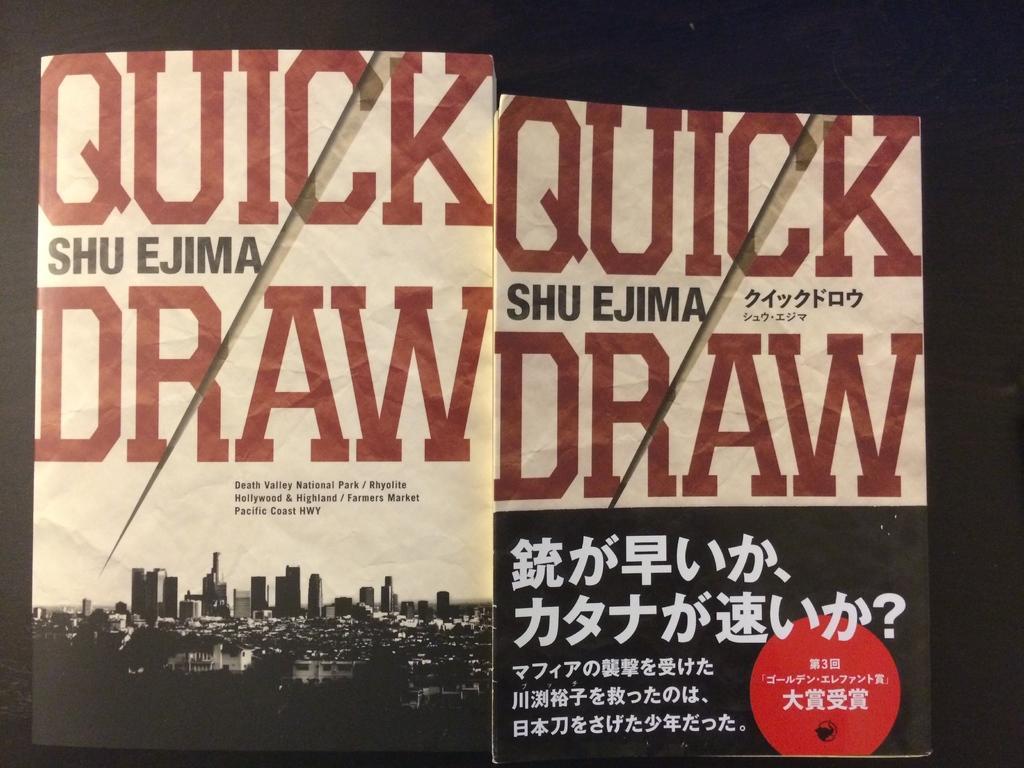Describe this image in one or two sentences. In this picture we can observe two posters. We can observe some buildings on this poster. There is some text which is in red color on this poster. The background is completely dark. 